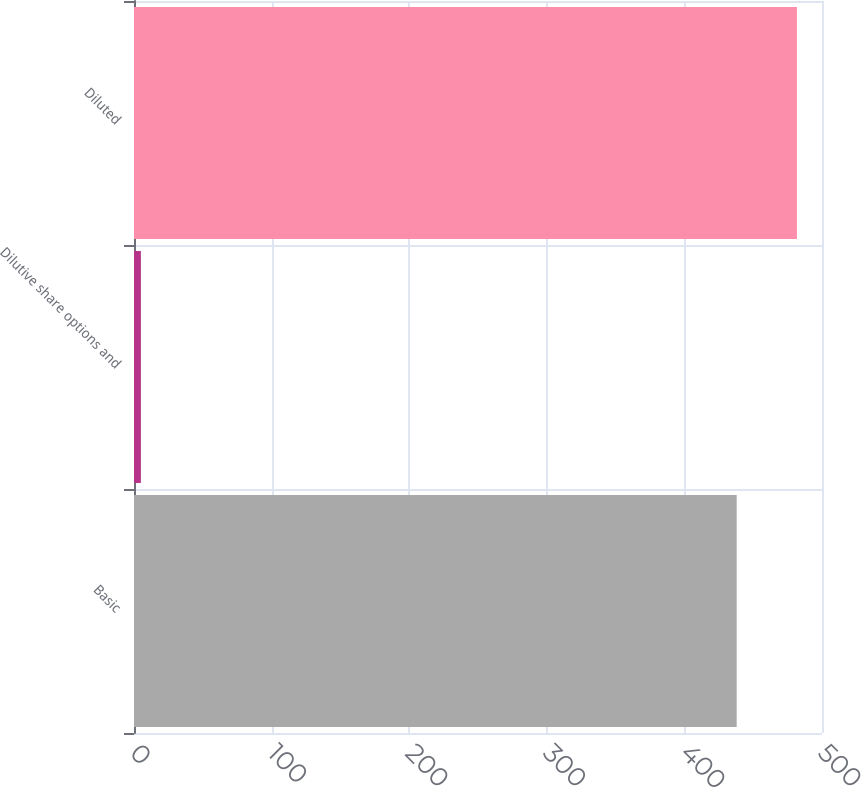Convert chart. <chart><loc_0><loc_0><loc_500><loc_500><bar_chart><fcel>Basic<fcel>Dilutive share options and<fcel>Diluted<nl><fcel>438<fcel>5<fcel>481.8<nl></chart> 